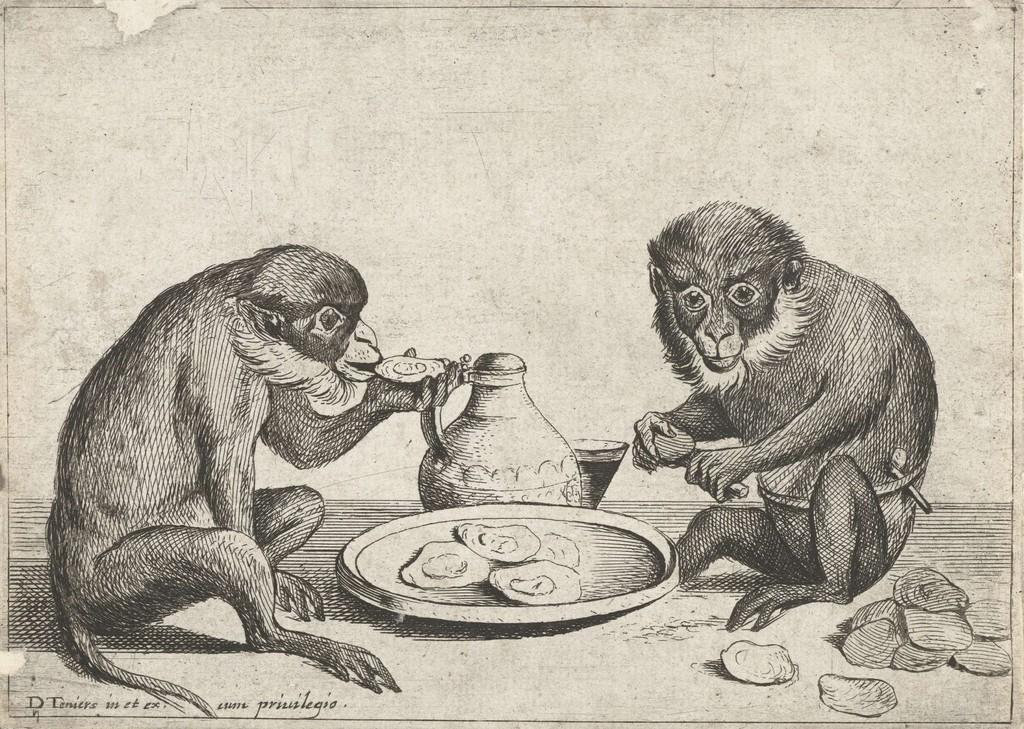What is the main subject of the image? The image contains a painting. What animals are depicted in the painting? There are monkeys in the painting. What objects can be seen in the painting besides the monkeys? There is a plate and a jug in the painting. What type of thrill can be seen on the faces of the cats in the painting? There are no cats present in the painting; it features monkeys instead. 